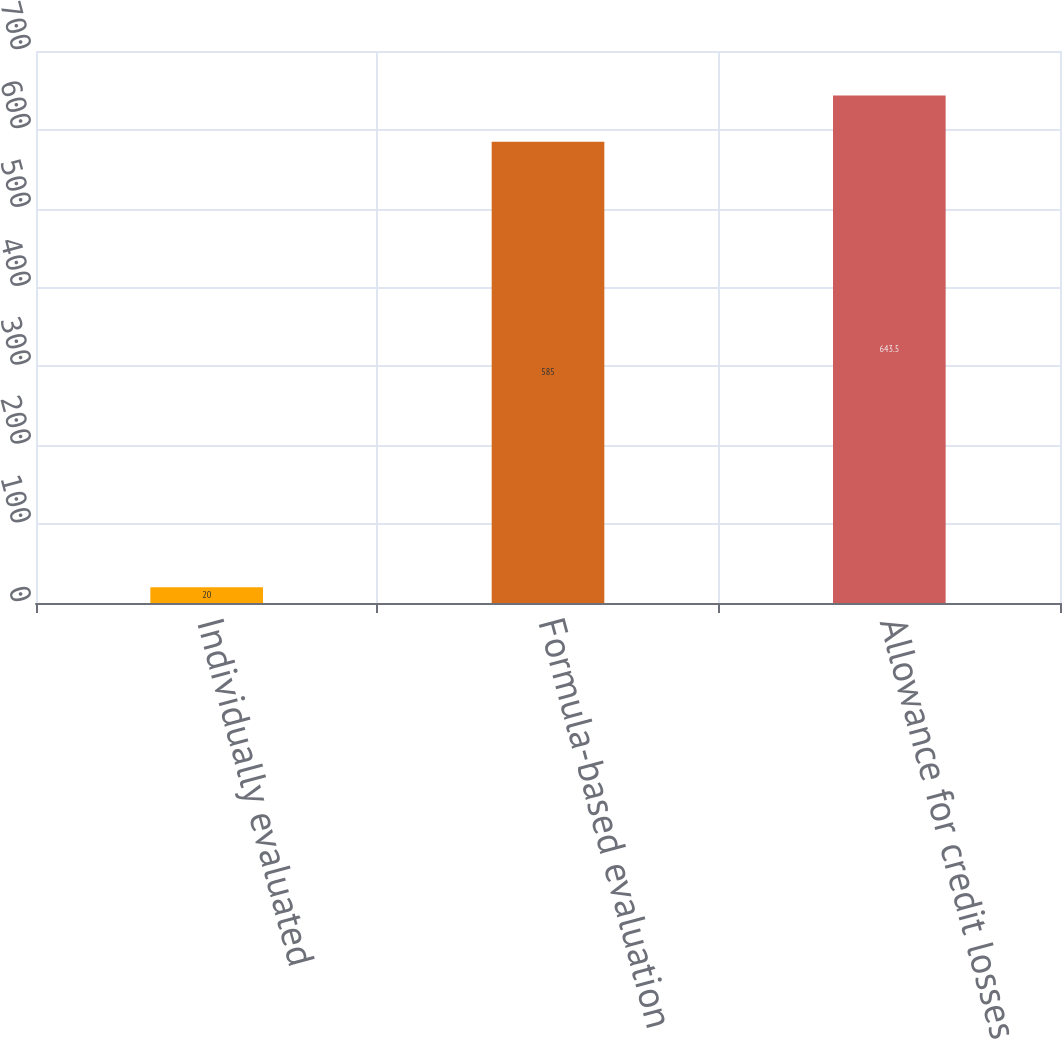Convert chart. <chart><loc_0><loc_0><loc_500><loc_500><bar_chart><fcel>Individually evaluated<fcel>Formula-based evaluation<fcel>Allowance for credit losses<nl><fcel>20<fcel>585<fcel>643.5<nl></chart> 